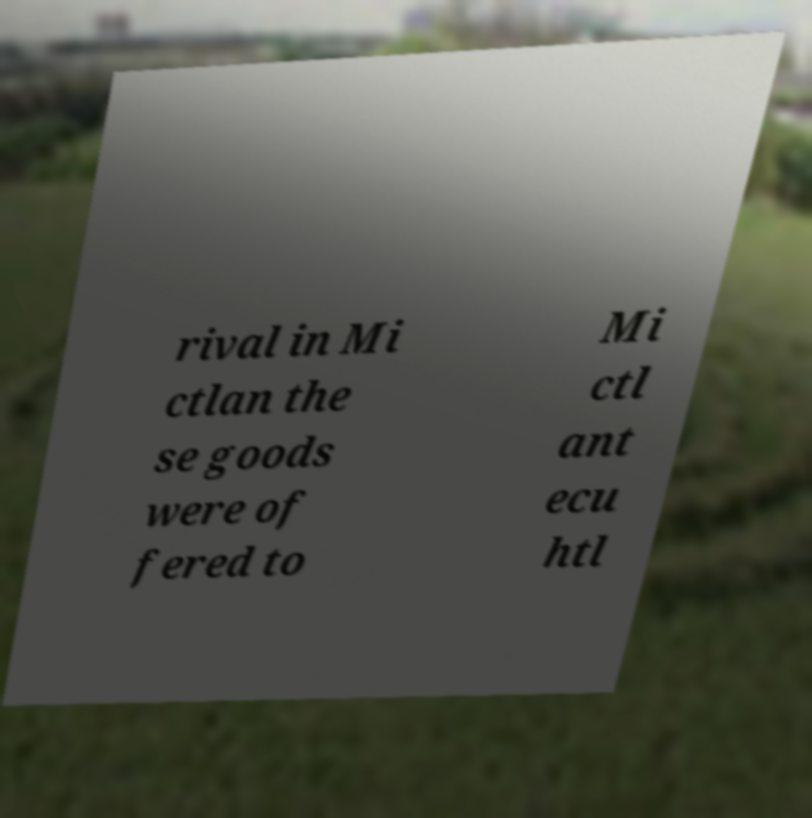There's text embedded in this image that I need extracted. Can you transcribe it verbatim? rival in Mi ctlan the se goods were of fered to Mi ctl ant ecu htl 